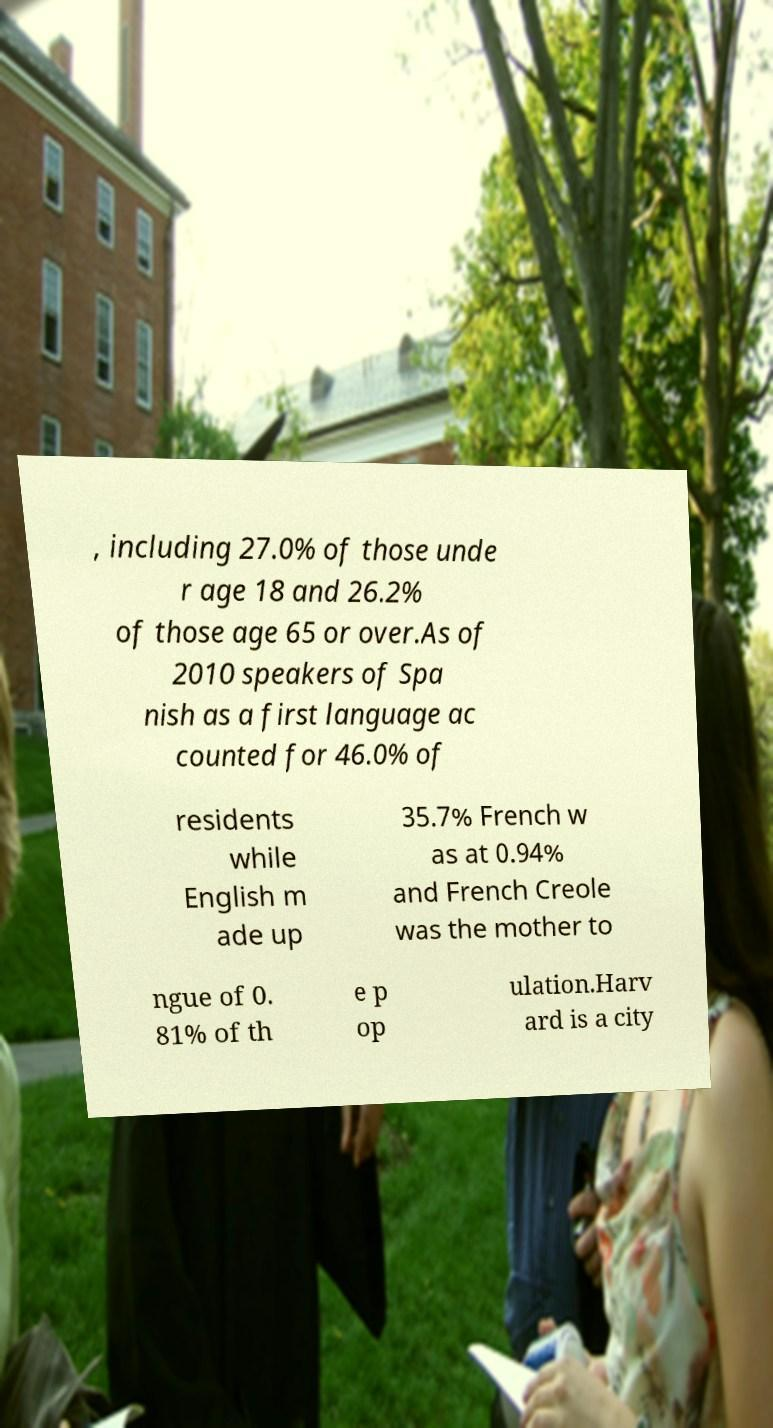Could you assist in decoding the text presented in this image and type it out clearly? , including 27.0% of those unde r age 18 and 26.2% of those age 65 or over.As of 2010 speakers of Spa nish as a first language ac counted for 46.0% of residents while English m ade up 35.7% French w as at 0.94% and French Creole was the mother to ngue of 0. 81% of th e p op ulation.Harv ard is a city 